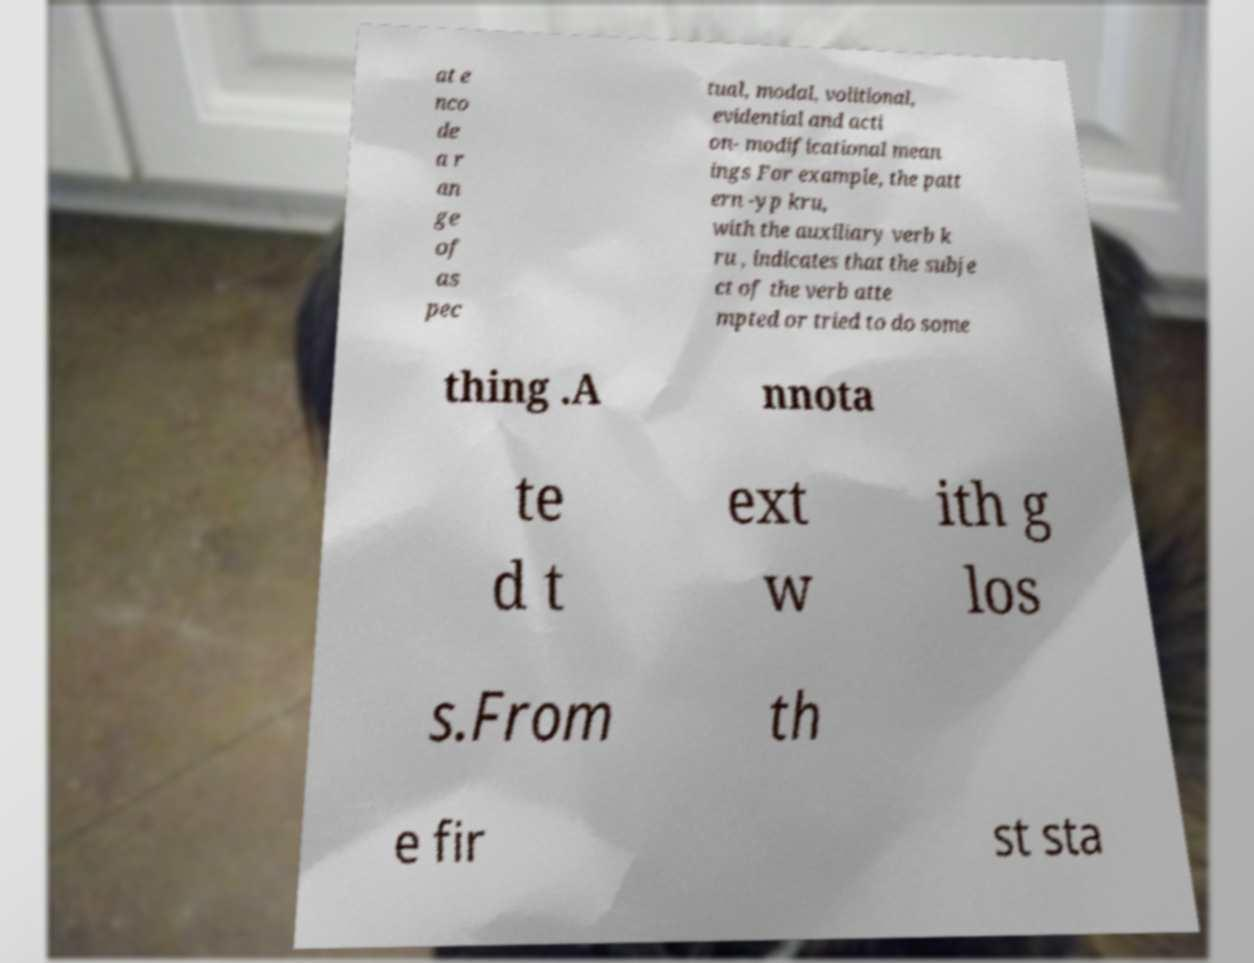Please identify and transcribe the text found in this image. at e nco de a r an ge of as pec tual, modal, volitional, evidential and acti on- modificational mean ings For example, the patt ern -yp kru, with the auxiliary verb k ru , indicates that the subje ct of the verb atte mpted or tried to do some thing .A nnota te d t ext w ith g los s.From th e fir st sta 